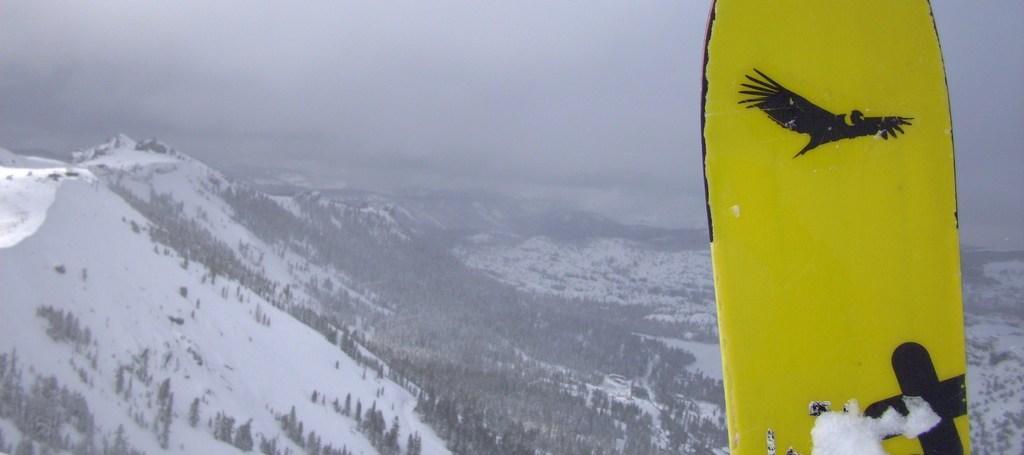In one or two sentences, can you explain what this image depicts? In the picture we can see an Aerial view of the mountains covered with snow and trees and near it, we can see a snowboard which is yellow in color and some bird painting on it, and in the background we can see a fog. 